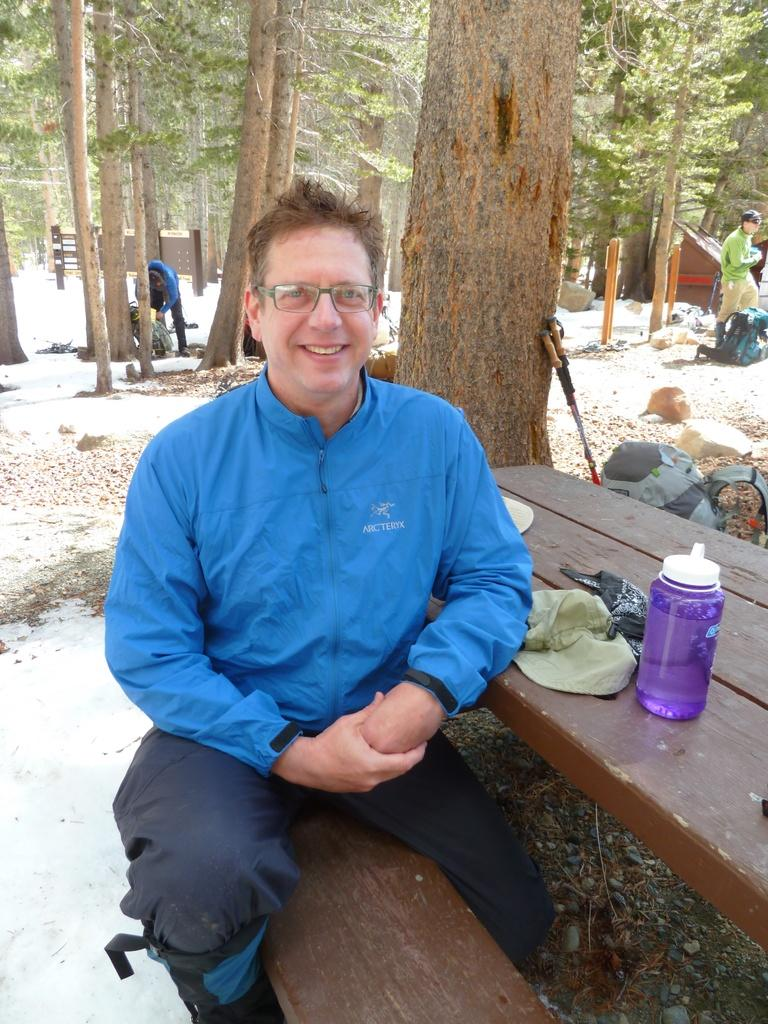Who is present in the image? There is a man in the image. What is the man wearing? The man is wearing a blue jacket. What is the man doing in the image? The man is sitting on a chair. What can be seen on the table in the image? There is a bottle on the table. What is visible in the background of the image? Trees, plants, and people are visible in the background of the image. What type of bomb can be seen on the table in the image? There is no bomb present on the table in the image; only a bottle is visible. How many jellyfish are swimming in the background of the image? There are no jellyfish present in the background of the image; only trees, plants, and people are visible. 